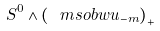<formula> <loc_0><loc_0><loc_500><loc_500>S ^ { 0 } \wedge \left ( \ m s o b w u _ { - m } \right ) _ { + }</formula> 